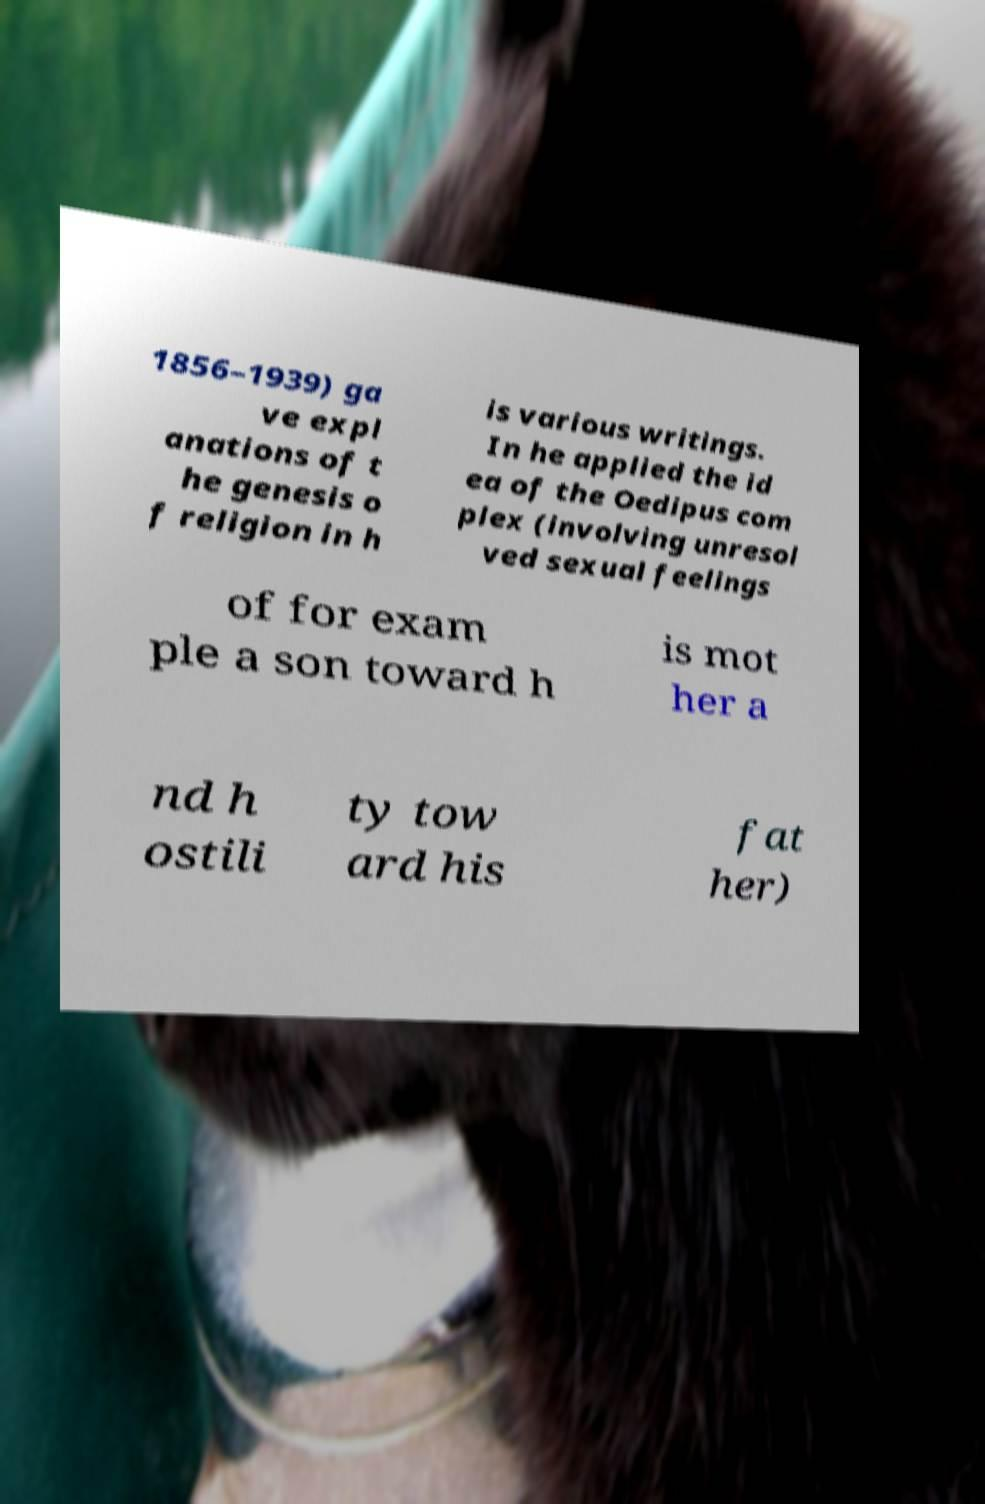Could you extract and type out the text from this image? 1856–1939) ga ve expl anations of t he genesis o f religion in h is various writings. In he applied the id ea of the Oedipus com plex (involving unresol ved sexual feelings of for exam ple a son toward h is mot her a nd h ostili ty tow ard his fat her) 